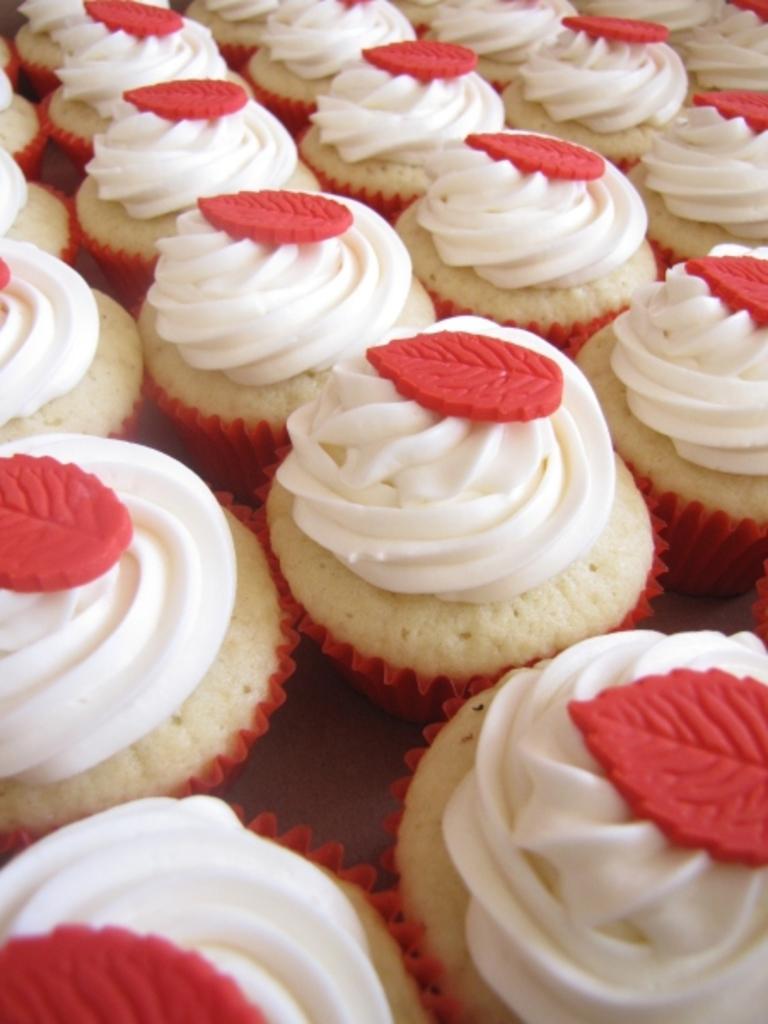Describe this image in one or two sentences. In this image we can see some cupcakes with whipped cream. 